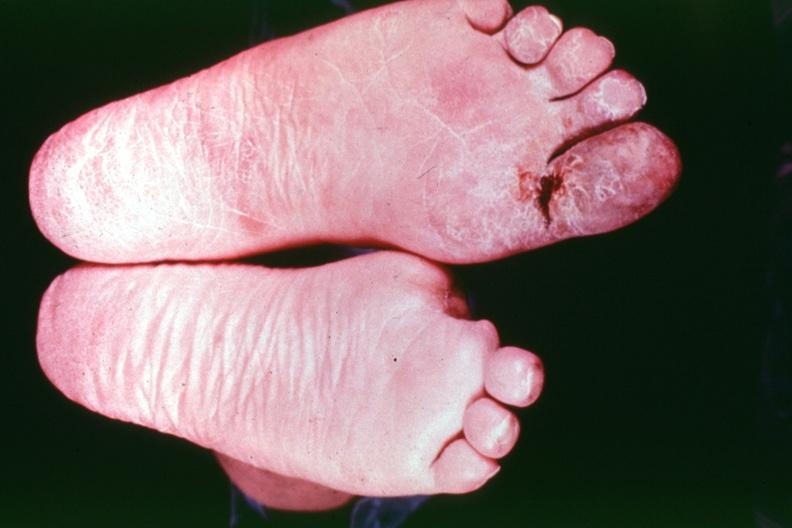what are present?
Answer the question using a single word or phrase. Extremities 